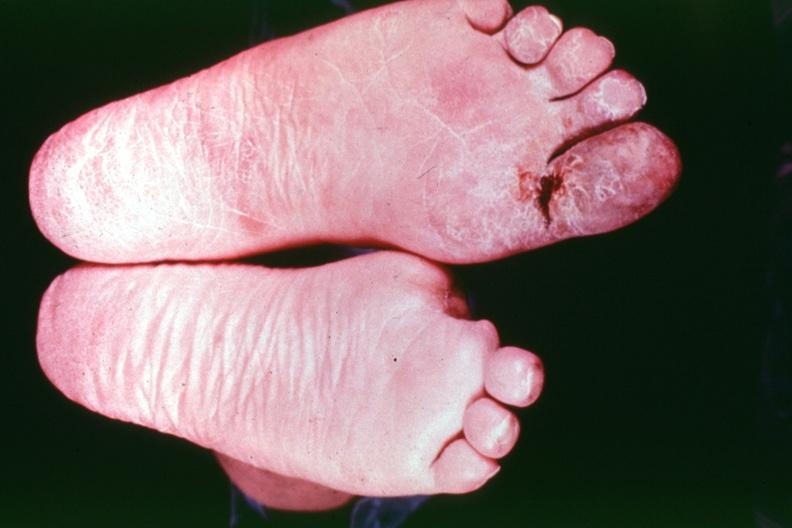what are present?
Answer the question using a single word or phrase. Extremities 